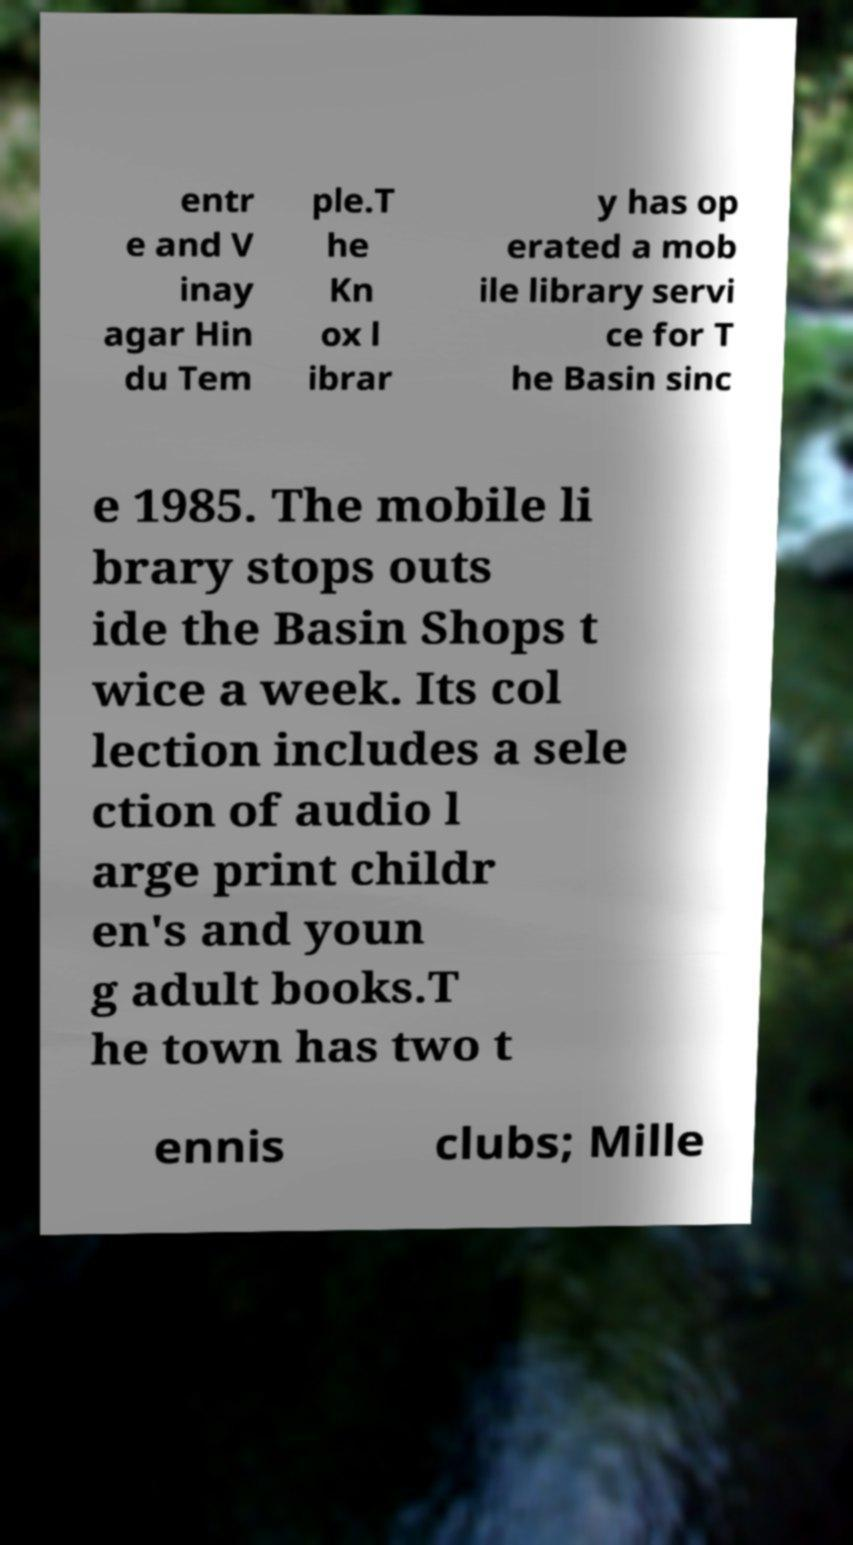For documentation purposes, I need the text within this image transcribed. Could you provide that? entr e and V inay agar Hin du Tem ple.T he Kn ox l ibrar y has op erated a mob ile library servi ce for T he Basin sinc e 1985. The mobile li brary stops outs ide the Basin Shops t wice a week. Its col lection includes a sele ction of audio l arge print childr en's and youn g adult books.T he town has two t ennis clubs; Mille 